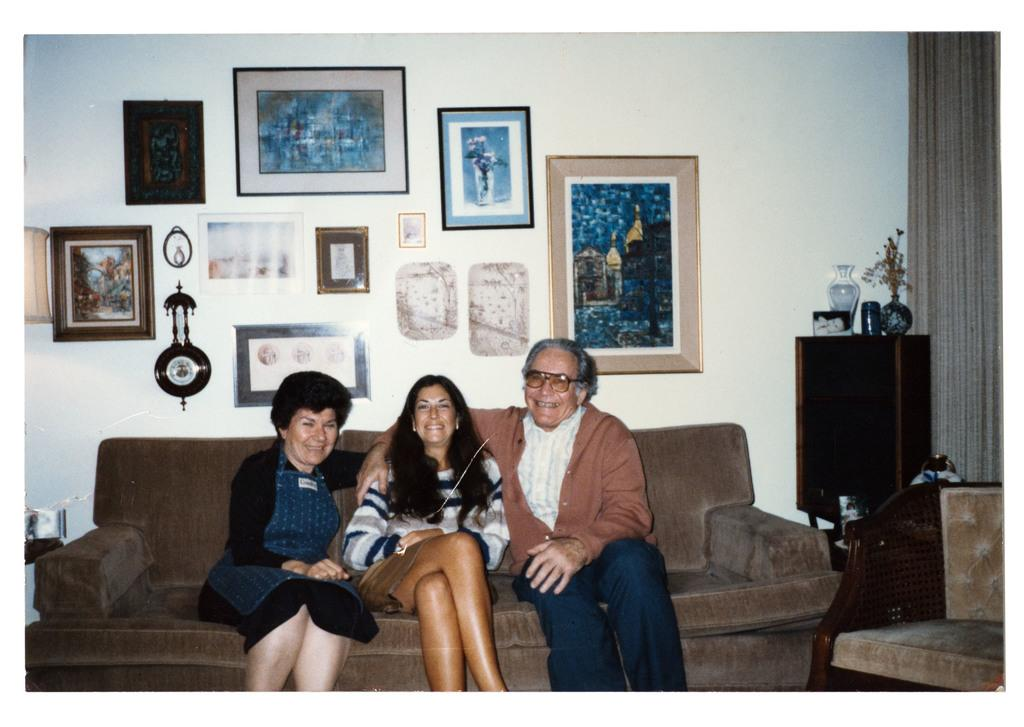How many people are in the image? There are three people in the image. What are the people doing in the image? The people are sitting on a sofa and smiling. What can be seen in the background of the image? There is a wall, photo frames, a clock, a flower vase, a curtain, and other objects visible in the background of the image. What type of punishment is being administered to the people in the image? There is no punishment being administered to the people in the image; they are sitting on a sofa and smiling. What type of church is visible in the background of the image? There is no church visible in the background of the image; only a wall, photo frames, a clock, a flower vase, a curtain, and other objects can be seen. 